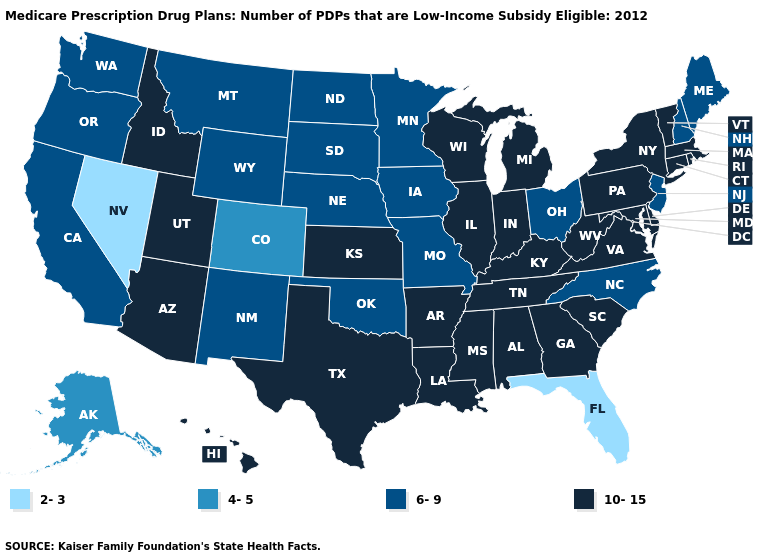Does New Hampshire have the highest value in the USA?
Be succinct. No. Which states have the lowest value in the USA?
Concise answer only. Florida, Nevada. Name the states that have a value in the range 10-15?
Keep it brief. Alabama, Arkansas, Arizona, Connecticut, Delaware, Georgia, Hawaii, Idaho, Illinois, Indiana, Kansas, Kentucky, Louisiana, Massachusetts, Maryland, Michigan, Mississippi, New York, Pennsylvania, Rhode Island, South Carolina, Tennessee, Texas, Utah, Virginia, Vermont, Wisconsin, West Virginia. Does the map have missing data?
Short answer required. No. What is the value of Hawaii?
Be succinct. 10-15. What is the value of Rhode Island?
Answer briefly. 10-15. What is the value of Wisconsin?
Write a very short answer. 10-15. Name the states that have a value in the range 4-5?
Be succinct. Alaska, Colorado. Does Alaska have a higher value than Nevada?
Give a very brief answer. Yes. Does the first symbol in the legend represent the smallest category?
Concise answer only. Yes. Name the states that have a value in the range 6-9?
Short answer required. California, Iowa, Maine, Minnesota, Missouri, Montana, North Carolina, North Dakota, Nebraska, New Hampshire, New Jersey, New Mexico, Ohio, Oklahoma, Oregon, South Dakota, Washington, Wyoming. What is the lowest value in the MidWest?
Concise answer only. 6-9. What is the lowest value in states that border California?
Short answer required. 2-3. Name the states that have a value in the range 4-5?
Short answer required. Alaska, Colorado. Is the legend a continuous bar?
Answer briefly. No. 